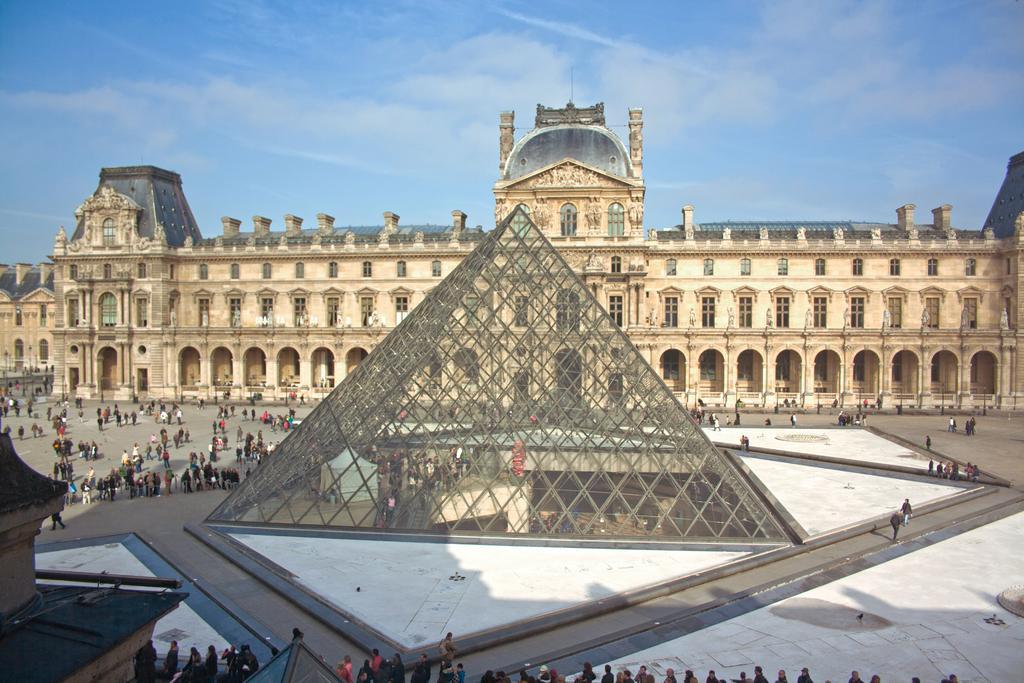How would you summarize this image in a sentence or two? In this image I can see number of people are standing. I can also see few buildings, windows and in background I can see clouds and the sky. 